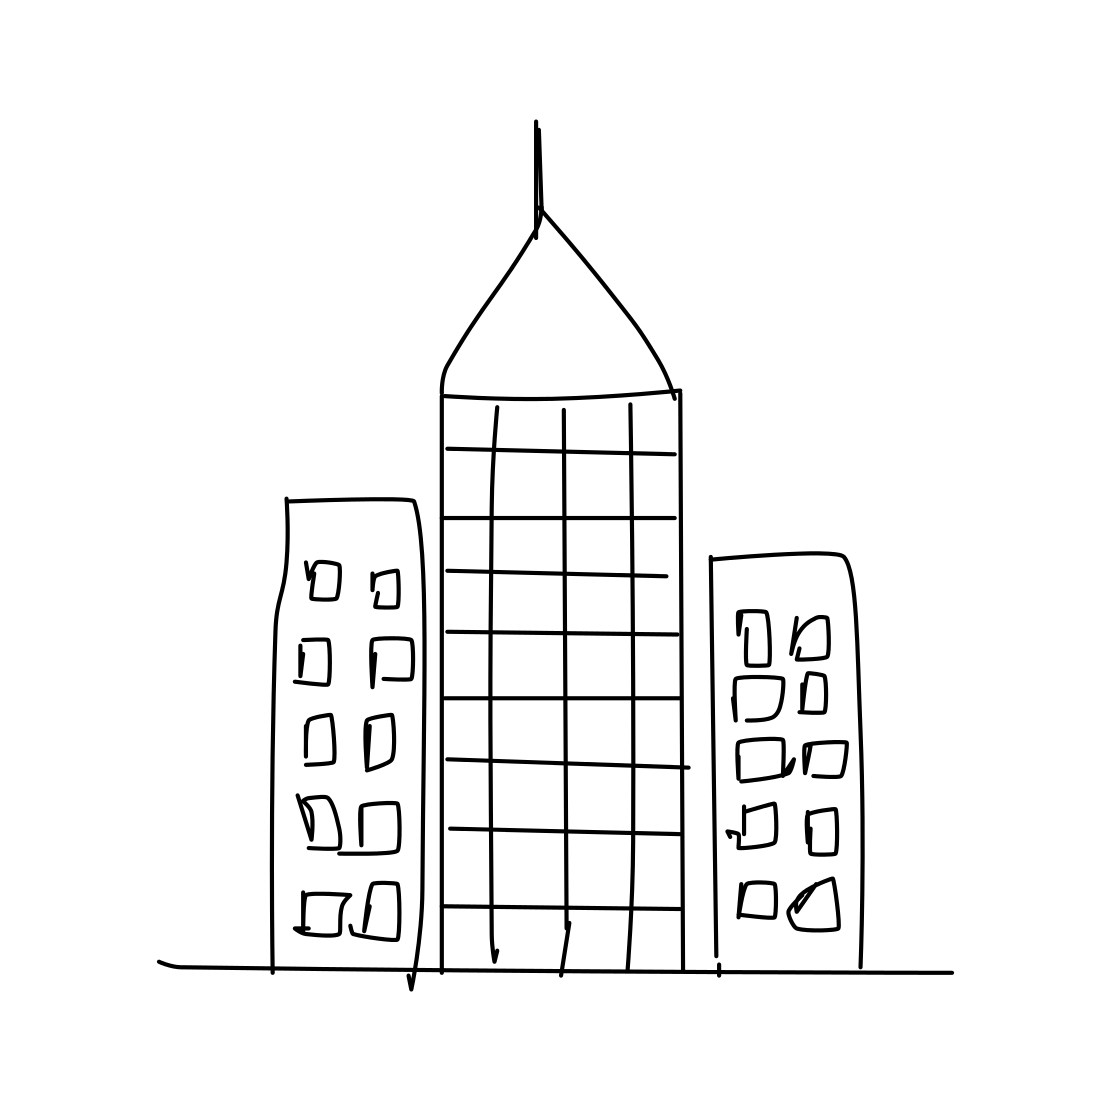Can you tell me what style this drawing is? The drawing is executed in a minimalistic, sketch-like style, with clean lines and little detail, conveying the basic shapes and structures of the buildings. 